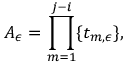<formula> <loc_0><loc_0><loc_500><loc_500>A _ { \epsilon } = \prod _ { m = 1 } ^ { j - i } \{ t _ { m , \epsilon } \} ,</formula> 